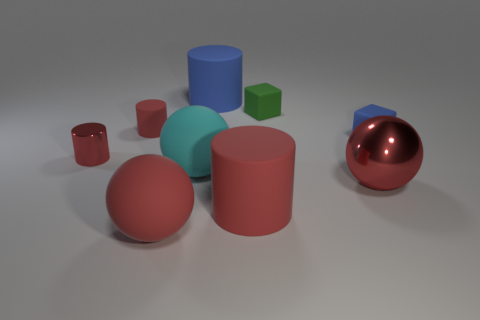Subtract all red blocks. How many red cylinders are left? 3 Subtract all blue cylinders. How many cylinders are left? 3 Subtract all red cylinders. How many cylinders are left? 1 Subtract all purple cylinders. Subtract all cyan blocks. How many cylinders are left? 4 Add 1 small blue cubes. How many objects exist? 10 Subtract all cubes. How many objects are left? 7 Subtract all red rubber objects. Subtract all cyan balls. How many objects are left? 5 Add 6 cyan balls. How many cyan balls are left? 7 Add 2 small blue rubber objects. How many small blue rubber objects exist? 3 Subtract 0 yellow cylinders. How many objects are left? 9 